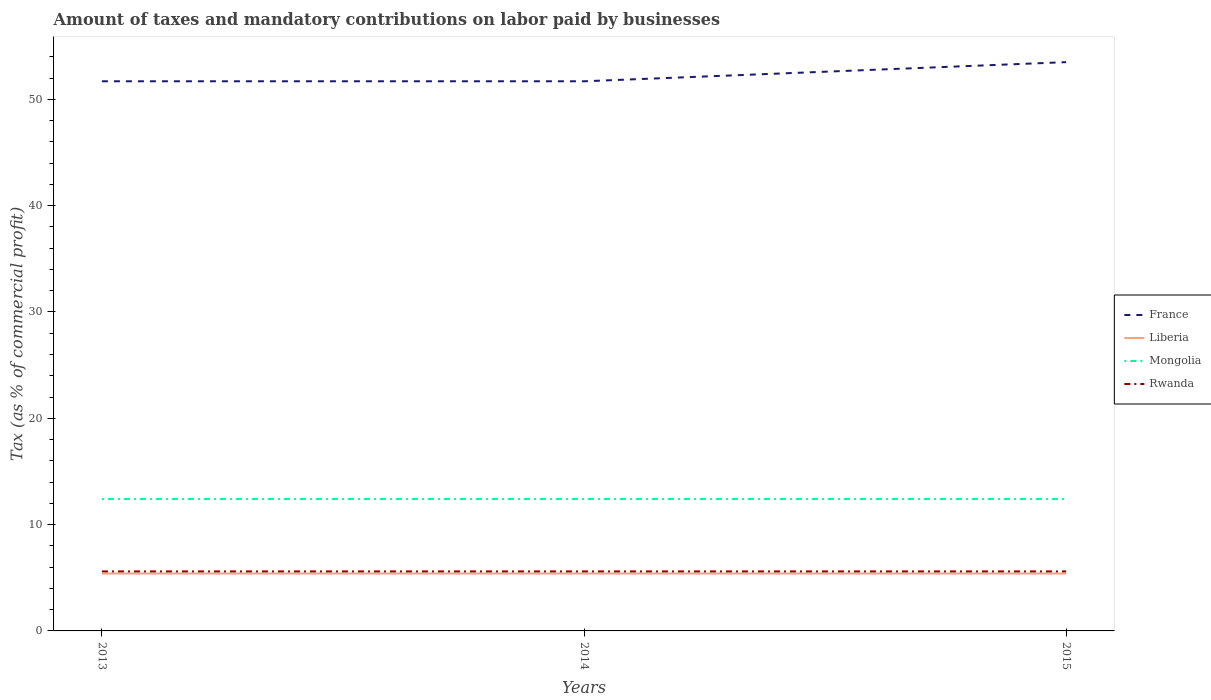How many different coloured lines are there?
Make the answer very short. 4. Across all years, what is the maximum percentage of taxes paid by businesses in France?
Keep it short and to the point. 51.7. In which year was the percentage of taxes paid by businesses in Liberia maximum?
Keep it short and to the point. 2013. What is the difference between the highest and the second highest percentage of taxes paid by businesses in France?
Provide a succinct answer. 1.8. What is the difference between the highest and the lowest percentage of taxes paid by businesses in Rwanda?
Your answer should be very brief. 3. Is the percentage of taxes paid by businesses in Rwanda strictly greater than the percentage of taxes paid by businesses in Liberia over the years?
Your response must be concise. No. How many lines are there?
Give a very brief answer. 4. How many years are there in the graph?
Your answer should be very brief. 3. Are the values on the major ticks of Y-axis written in scientific E-notation?
Your answer should be very brief. No. Does the graph contain any zero values?
Provide a succinct answer. No. Does the graph contain grids?
Keep it short and to the point. No. Where does the legend appear in the graph?
Provide a succinct answer. Center right. What is the title of the graph?
Offer a very short reply. Amount of taxes and mandatory contributions on labor paid by businesses. Does "Cabo Verde" appear as one of the legend labels in the graph?
Provide a succinct answer. No. What is the label or title of the X-axis?
Your response must be concise. Years. What is the label or title of the Y-axis?
Provide a succinct answer. Tax (as % of commercial profit). What is the Tax (as % of commercial profit) in France in 2013?
Make the answer very short. 51.7. What is the Tax (as % of commercial profit) in Liberia in 2013?
Give a very brief answer. 5.4. What is the Tax (as % of commercial profit) of Mongolia in 2013?
Offer a terse response. 12.4. What is the Tax (as % of commercial profit) in France in 2014?
Offer a very short reply. 51.7. What is the Tax (as % of commercial profit) in Liberia in 2014?
Provide a short and direct response. 5.4. What is the Tax (as % of commercial profit) in Mongolia in 2014?
Give a very brief answer. 12.4. What is the Tax (as % of commercial profit) in Rwanda in 2014?
Provide a short and direct response. 5.6. What is the Tax (as % of commercial profit) of France in 2015?
Your response must be concise. 53.5. What is the Tax (as % of commercial profit) in Liberia in 2015?
Your answer should be compact. 5.4. Across all years, what is the maximum Tax (as % of commercial profit) in France?
Offer a very short reply. 53.5. Across all years, what is the maximum Tax (as % of commercial profit) in Rwanda?
Provide a short and direct response. 5.6. Across all years, what is the minimum Tax (as % of commercial profit) of France?
Provide a succinct answer. 51.7. Across all years, what is the minimum Tax (as % of commercial profit) of Liberia?
Offer a very short reply. 5.4. Across all years, what is the minimum Tax (as % of commercial profit) in Mongolia?
Ensure brevity in your answer.  12.4. Across all years, what is the minimum Tax (as % of commercial profit) in Rwanda?
Ensure brevity in your answer.  5.6. What is the total Tax (as % of commercial profit) of France in the graph?
Provide a short and direct response. 156.9. What is the total Tax (as % of commercial profit) in Mongolia in the graph?
Ensure brevity in your answer.  37.2. What is the difference between the Tax (as % of commercial profit) of Rwanda in 2013 and that in 2014?
Offer a very short reply. 0. What is the difference between the Tax (as % of commercial profit) in France in 2014 and that in 2015?
Provide a succinct answer. -1.8. What is the difference between the Tax (as % of commercial profit) of Mongolia in 2014 and that in 2015?
Keep it short and to the point. 0. What is the difference between the Tax (as % of commercial profit) of Rwanda in 2014 and that in 2015?
Ensure brevity in your answer.  0. What is the difference between the Tax (as % of commercial profit) in France in 2013 and the Tax (as % of commercial profit) in Liberia in 2014?
Offer a terse response. 46.3. What is the difference between the Tax (as % of commercial profit) in France in 2013 and the Tax (as % of commercial profit) in Mongolia in 2014?
Offer a very short reply. 39.3. What is the difference between the Tax (as % of commercial profit) in France in 2013 and the Tax (as % of commercial profit) in Rwanda in 2014?
Your answer should be compact. 46.1. What is the difference between the Tax (as % of commercial profit) of Liberia in 2013 and the Tax (as % of commercial profit) of Mongolia in 2014?
Your answer should be very brief. -7. What is the difference between the Tax (as % of commercial profit) in Liberia in 2013 and the Tax (as % of commercial profit) in Rwanda in 2014?
Your answer should be compact. -0.2. What is the difference between the Tax (as % of commercial profit) of France in 2013 and the Tax (as % of commercial profit) of Liberia in 2015?
Your answer should be very brief. 46.3. What is the difference between the Tax (as % of commercial profit) of France in 2013 and the Tax (as % of commercial profit) of Mongolia in 2015?
Provide a short and direct response. 39.3. What is the difference between the Tax (as % of commercial profit) in France in 2013 and the Tax (as % of commercial profit) in Rwanda in 2015?
Your response must be concise. 46.1. What is the difference between the Tax (as % of commercial profit) of Mongolia in 2013 and the Tax (as % of commercial profit) of Rwanda in 2015?
Your response must be concise. 6.8. What is the difference between the Tax (as % of commercial profit) of France in 2014 and the Tax (as % of commercial profit) of Liberia in 2015?
Make the answer very short. 46.3. What is the difference between the Tax (as % of commercial profit) of France in 2014 and the Tax (as % of commercial profit) of Mongolia in 2015?
Offer a very short reply. 39.3. What is the difference between the Tax (as % of commercial profit) in France in 2014 and the Tax (as % of commercial profit) in Rwanda in 2015?
Your answer should be compact. 46.1. What is the difference between the Tax (as % of commercial profit) in Liberia in 2014 and the Tax (as % of commercial profit) in Mongolia in 2015?
Provide a short and direct response. -7. What is the difference between the Tax (as % of commercial profit) in Liberia in 2014 and the Tax (as % of commercial profit) in Rwanda in 2015?
Keep it short and to the point. -0.2. What is the average Tax (as % of commercial profit) in France per year?
Your response must be concise. 52.3. What is the average Tax (as % of commercial profit) in Liberia per year?
Provide a short and direct response. 5.4. What is the average Tax (as % of commercial profit) of Mongolia per year?
Your response must be concise. 12.4. In the year 2013, what is the difference between the Tax (as % of commercial profit) of France and Tax (as % of commercial profit) of Liberia?
Offer a very short reply. 46.3. In the year 2013, what is the difference between the Tax (as % of commercial profit) of France and Tax (as % of commercial profit) of Mongolia?
Keep it short and to the point. 39.3. In the year 2013, what is the difference between the Tax (as % of commercial profit) in France and Tax (as % of commercial profit) in Rwanda?
Offer a terse response. 46.1. In the year 2013, what is the difference between the Tax (as % of commercial profit) in Liberia and Tax (as % of commercial profit) in Mongolia?
Offer a very short reply. -7. In the year 2013, what is the difference between the Tax (as % of commercial profit) in Liberia and Tax (as % of commercial profit) in Rwanda?
Offer a terse response. -0.2. In the year 2013, what is the difference between the Tax (as % of commercial profit) in Mongolia and Tax (as % of commercial profit) in Rwanda?
Give a very brief answer. 6.8. In the year 2014, what is the difference between the Tax (as % of commercial profit) in France and Tax (as % of commercial profit) in Liberia?
Ensure brevity in your answer.  46.3. In the year 2014, what is the difference between the Tax (as % of commercial profit) in France and Tax (as % of commercial profit) in Mongolia?
Make the answer very short. 39.3. In the year 2014, what is the difference between the Tax (as % of commercial profit) in France and Tax (as % of commercial profit) in Rwanda?
Your answer should be very brief. 46.1. In the year 2014, what is the difference between the Tax (as % of commercial profit) in Mongolia and Tax (as % of commercial profit) in Rwanda?
Your answer should be very brief. 6.8. In the year 2015, what is the difference between the Tax (as % of commercial profit) in France and Tax (as % of commercial profit) in Liberia?
Offer a very short reply. 48.1. In the year 2015, what is the difference between the Tax (as % of commercial profit) in France and Tax (as % of commercial profit) in Mongolia?
Your answer should be compact. 41.1. In the year 2015, what is the difference between the Tax (as % of commercial profit) of France and Tax (as % of commercial profit) of Rwanda?
Ensure brevity in your answer.  47.9. In the year 2015, what is the difference between the Tax (as % of commercial profit) of Liberia and Tax (as % of commercial profit) of Mongolia?
Ensure brevity in your answer.  -7. What is the ratio of the Tax (as % of commercial profit) in France in 2013 to that in 2014?
Make the answer very short. 1. What is the ratio of the Tax (as % of commercial profit) in France in 2013 to that in 2015?
Keep it short and to the point. 0.97. What is the ratio of the Tax (as % of commercial profit) of Rwanda in 2013 to that in 2015?
Keep it short and to the point. 1. What is the ratio of the Tax (as % of commercial profit) in France in 2014 to that in 2015?
Give a very brief answer. 0.97. What is the ratio of the Tax (as % of commercial profit) in Liberia in 2014 to that in 2015?
Your answer should be very brief. 1. What is the ratio of the Tax (as % of commercial profit) in Mongolia in 2014 to that in 2015?
Ensure brevity in your answer.  1. What is the difference between the highest and the second highest Tax (as % of commercial profit) in Mongolia?
Offer a very short reply. 0. 